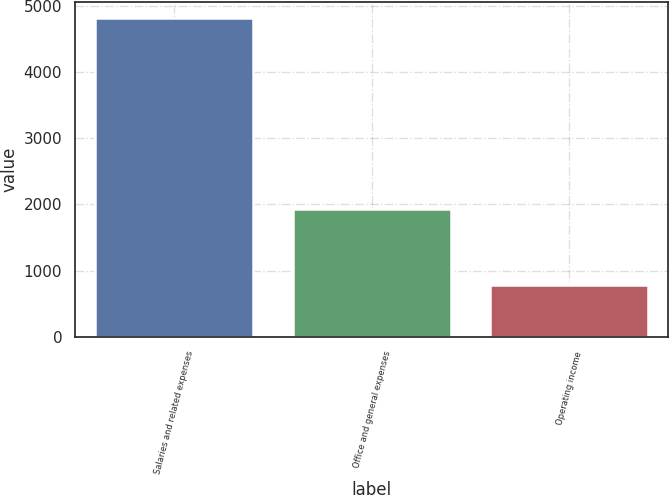<chart> <loc_0><loc_0><loc_500><loc_500><bar_chart><fcel>Salaries and related expenses<fcel>Office and general expenses<fcel>Operating income<nl><fcel>4820.4<fcel>1928.3<fcel>788.4<nl></chart> 